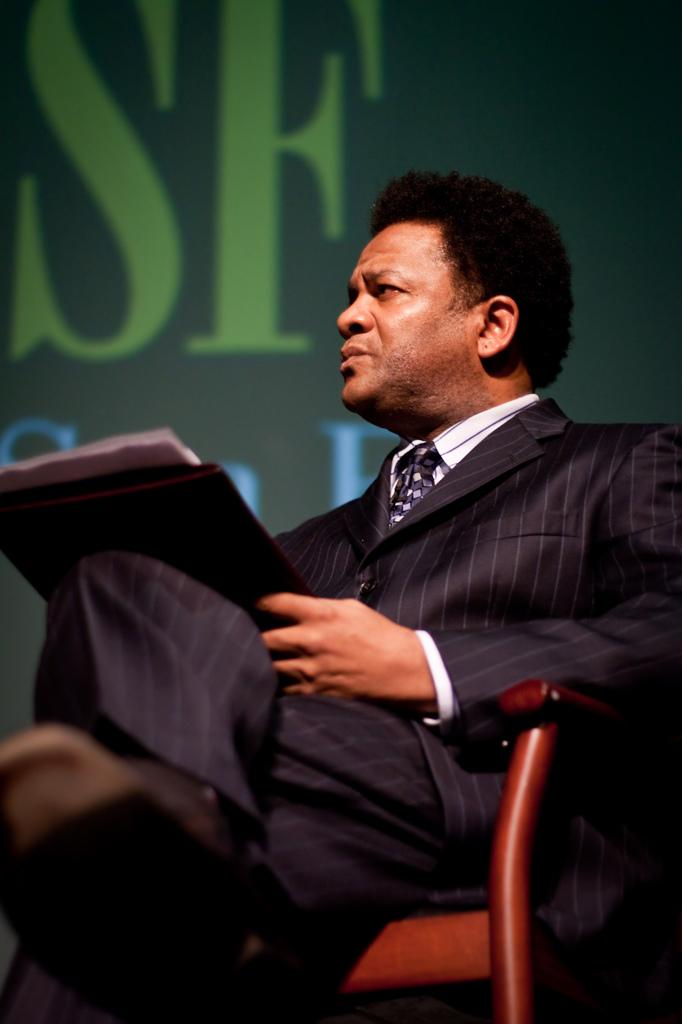Who is present in the image? There is a man in the image. What is the man doing in the image? The man is sitting on a chair and holding a file. What can be seen in the background of the image? There are words visible in the background of the image. What is the man's emotional state in the image? The image does not provide any information about the man's emotional state, so it cannot be determined. 